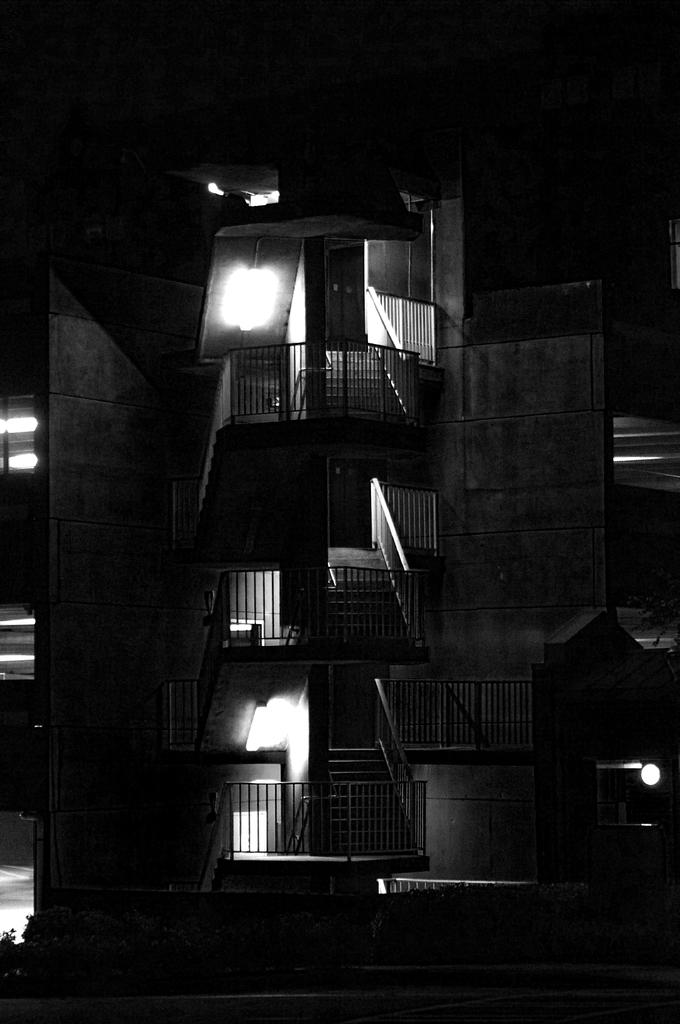What type of structures can be seen in the image? There are buildings in the image. What is the material of the fence in the image? The fence in the image is made of metal. What can be used to illuminate the area in the image? There are lights in the image. What type of vegetation is present in the image? There are plants in the image. What type of vessel is being used to transport the screws in the image? There is no vessel or screws present in the image. 